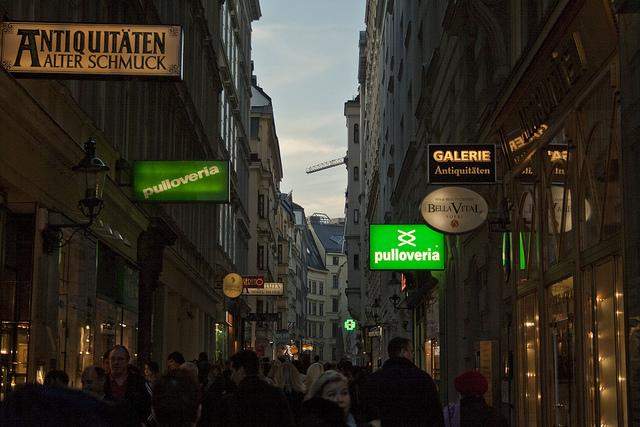Where is Pulloveria based? vienna 